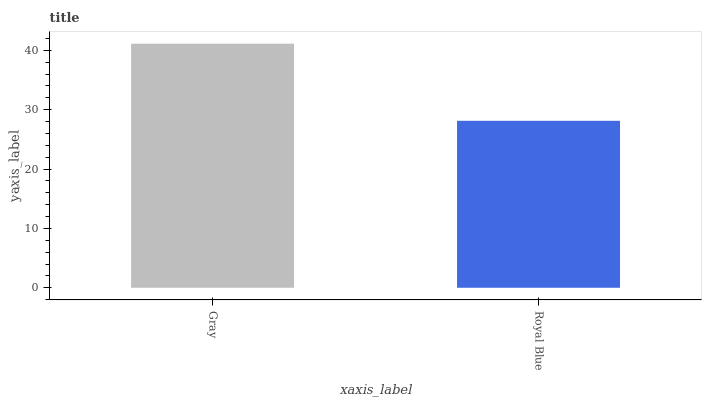Is Royal Blue the minimum?
Answer yes or no. Yes. Is Gray the maximum?
Answer yes or no. Yes. Is Royal Blue the maximum?
Answer yes or no. No. Is Gray greater than Royal Blue?
Answer yes or no. Yes. Is Royal Blue less than Gray?
Answer yes or no. Yes. Is Royal Blue greater than Gray?
Answer yes or no. No. Is Gray less than Royal Blue?
Answer yes or no. No. Is Gray the high median?
Answer yes or no. Yes. Is Royal Blue the low median?
Answer yes or no. Yes. Is Royal Blue the high median?
Answer yes or no. No. Is Gray the low median?
Answer yes or no. No. 